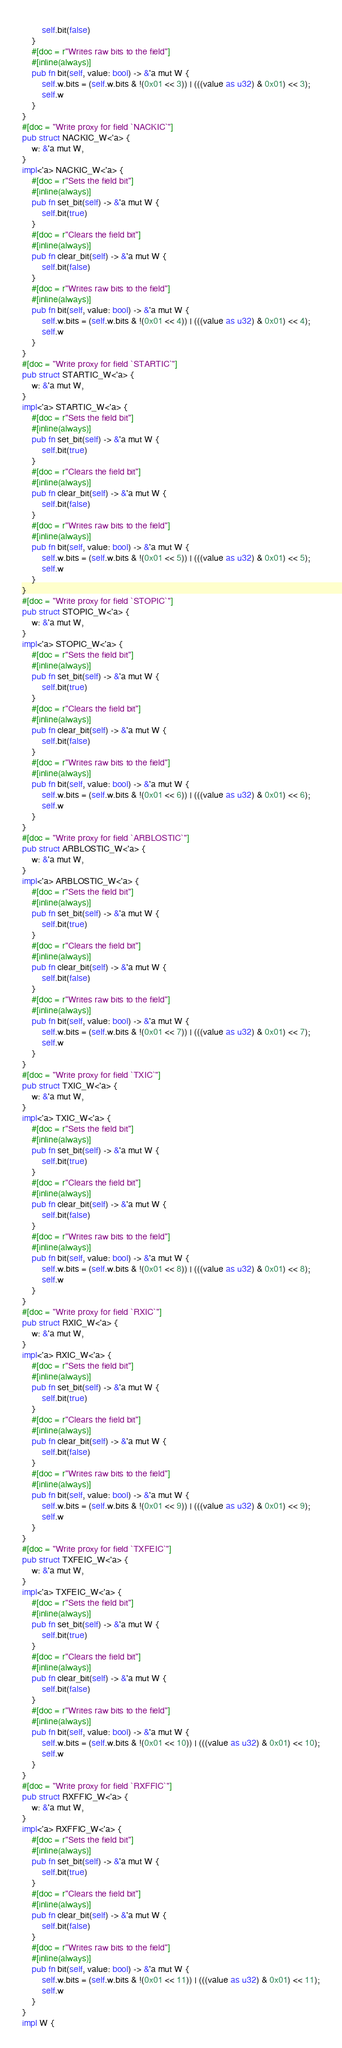<code> <loc_0><loc_0><loc_500><loc_500><_Rust_>        self.bit(false)
    }
    #[doc = r"Writes raw bits to the field"]
    #[inline(always)]
    pub fn bit(self, value: bool) -> &'a mut W {
        self.w.bits = (self.w.bits & !(0x01 << 3)) | (((value as u32) & 0x01) << 3);
        self.w
    }
}
#[doc = "Write proxy for field `NACKIC`"]
pub struct NACKIC_W<'a> {
    w: &'a mut W,
}
impl<'a> NACKIC_W<'a> {
    #[doc = r"Sets the field bit"]
    #[inline(always)]
    pub fn set_bit(self) -> &'a mut W {
        self.bit(true)
    }
    #[doc = r"Clears the field bit"]
    #[inline(always)]
    pub fn clear_bit(self) -> &'a mut W {
        self.bit(false)
    }
    #[doc = r"Writes raw bits to the field"]
    #[inline(always)]
    pub fn bit(self, value: bool) -> &'a mut W {
        self.w.bits = (self.w.bits & !(0x01 << 4)) | (((value as u32) & 0x01) << 4);
        self.w
    }
}
#[doc = "Write proxy for field `STARTIC`"]
pub struct STARTIC_W<'a> {
    w: &'a mut W,
}
impl<'a> STARTIC_W<'a> {
    #[doc = r"Sets the field bit"]
    #[inline(always)]
    pub fn set_bit(self) -> &'a mut W {
        self.bit(true)
    }
    #[doc = r"Clears the field bit"]
    #[inline(always)]
    pub fn clear_bit(self) -> &'a mut W {
        self.bit(false)
    }
    #[doc = r"Writes raw bits to the field"]
    #[inline(always)]
    pub fn bit(self, value: bool) -> &'a mut W {
        self.w.bits = (self.w.bits & !(0x01 << 5)) | (((value as u32) & 0x01) << 5);
        self.w
    }
}
#[doc = "Write proxy for field `STOPIC`"]
pub struct STOPIC_W<'a> {
    w: &'a mut W,
}
impl<'a> STOPIC_W<'a> {
    #[doc = r"Sets the field bit"]
    #[inline(always)]
    pub fn set_bit(self) -> &'a mut W {
        self.bit(true)
    }
    #[doc = r"Clears the field bit"]
    #[inline(always)]
    pub fn clear_bit(self) -> &'a mut W {
        self.bit(false)
    }
    #[doc = r"Writes raw bits to the field"]
    #[inline(always)]
    pub fn bit(self, value: bool) -> &'a mut W {
        self.w.bits = (self.w.bits & !(0x01 << 6)) | (((value as u32) & 0x01) << 6);
        self.w
    }
}
#[doc = "Write proxy for field `ARBLOSTIC`"]
pub struct ARBLOSTIC_W<'a> {
    w: &'a mut W,
}
impl<'a> ARBLOSTIC_W<'a> {
    #[doc = r"Sets the field bit"]
    #[inline(always)]
    pub fn set_bit(self) -> &'a mut W {
        self.bit(true)
    }
    #[doc = r"Clears the field bit"]
    #[inline(always)]
    pub fn clear_bit(self) -> &'a mut W {
        self.bit(false)
    }
    #[doc = r"Writes raw bits to the field"]
    #[inline(always)]
    pub fn bit(self, value: bool) -> &'a mut W {
        self.w.bits = (self.w.bits & !(0x01 << 7)) | (((value as u32) & 0x01) << 7);
        self.w
    }
}
#[doc = "Write proxy for field `TXIC`"]
pub struct TXIC_W<'a> {
    w: &'a mut W,
}
impl<'a> TXIC_W<'a> {
    #[doc = r"Sets the field bit"]
    #[inline(always)]
    pub fn set_bit(self) -> &'a mut W {
        self.bit(true)
    }
    #[doc = r"Clears the field bit"]
    #[inline(always)]
    pub fn clear_bit(self) -> &'a mut W {
        self.bit(false)
    }
    #[doc = r"Writes raw bits to the field"]
    #[inline(always)]
    pub fn bit(self, value: bool) -> &'a mut W {
        self.w.bits = (self.w.bits & !(0x01 << 8)) | (((value as u32) & 0x01) << 8);
        self.w
    }
}
#[doc = "Write proxy for field `RXIC`"]
pub struct RXIC_W<'a> {
    w: &'a mut W,
}
impl<'a> RXIC_W<'a> {
    #[doc = r"Sets the field bit"]
    #[inline(always)]
    pub fn set_bit(self) -> &'a mut W {
        self.bit(true)
    }
    #[doc = r"Clears the field bit"]
    #[inline(always)]
    pub fn clear_bit(self) -> &'a mut W {
        self.bit(false)
    }
    #[doc = r"Writes raw bits to the field"]
    #[inline(always)]
    pub fn bit(self, value: bool) -> &'a mut W {
        self.w.bits = (self.w.bits & !(0x01 << 9)) | (((value as u32) & 0x01) << 9);
        self.w
    }
}
#[doc = "Write proxy for field `TXFEIC`"]
pub struct TXFEIC_W<'a> {
    w: &'a mut W,
}
impl<'a> TXFEIC_W<'a> {
    #[doc = r"Sets the field bit"]
    #[inline(always)]
    pub fn set_bit(self) -> &'a mut W {
        self.bit(true)
    }
    #[doc = r"Clears the field bit"]
    #[inline(always)]
    pub fn clear_bit(self) -> &'a mut W {
        self.bit(false)
    }
    #[doc = r"Writes raw bits to the field"]
    #[inline(always)]
    pub fn bit(self, value: bool) -> &'a mut W {
        self.w.bits = (self.w.bits & !(0x01 << 10)) | (((value as u32) & 0x01) << 10);
        self.w
    }
}
#[doc = "Write proxy for field `RXFFIC`"]
pub struct RXFFIC_W<'a> {
    w: &'a mut W,
}
impl<'a> RXFFIC_W<'a> {
    #[doc = r"Sets the field bit"]
    #[inline(always)]
    pub fn set_bit(self) -> &'a mut W {
        self.bit(true)
    }
    #[doc = r"Clears the field bit"]
    #[inline(always)]
    pub fn clear_bit(self) -> &'a mut W {
        self.bit(false)
    }
    #[doc = r"Writes raw bits to the field"]
    #[inline(always)]
    pub fn bit(self, value: bool) -> &'a mut W {
        self.w.bits = (self.w.bits & !(0x01 << 11)) | (((value as u32) & 0x01) << 11);
        self.w
    }
}
impl W {</code> 